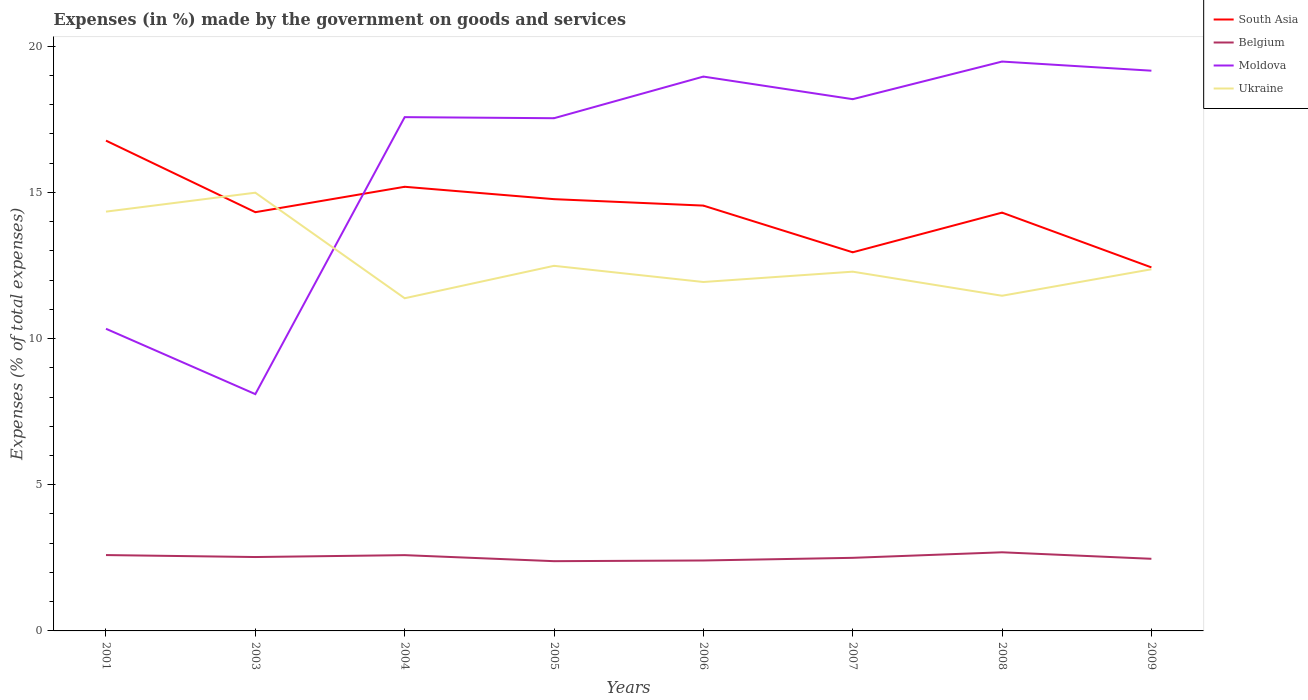How many different coloured lines are there?
Provide a short and direct response. 4. Is the number of lines equal to the number of legend labels?
Your answer should be very brief. Yes. Across all years, what is the maximum percentage of expenses made by the government on goods and services in Ukraine?
Give a very brief answer. 11.38. In which year was the percentage of expenses made by the government on goods and services in Belgium maximum?
Ensure brevity in your answer.  2005. What is the total percentage of expenses made by the government on goods and services in South Asia in the graph?
Make the answer very short. 1.89. What is the difference between the highest and the second highest percentage of expenses made by the government on goods and services in Ukraine?
Your response must be concise. 3.61. What is the difference between the highest and the lowest percentage of expenses made by the government on goods and services in South Asia?
Provide a short and direct response. 4. How many lines are there?
Provide a succinct answer. 4. How many years are there in the graph?
Your answer should be very brief. 8. What is the difference between two consecutive major ticks on the Y-axis?
Your response must be concise. 5. Are the values on the major ticks of Y-axis written in scientific E-notation?
Your response must be concise. No. Where does the legend appear in the graph?
Make the answer very short. Top right. What is the title of the graph?
Keep it short and to the point. Expenses (in %) made by the government on goods and services. What is the label or title of the X-axis?
Provide a succinct answer. Years. What is the label or title of the Y-axis?
Offer a terse response. Expenses (% of total expenses). What is the Expenses (% of total expenses) in South Asia in 2001?
Offer a very short reply. 16.77. What is the Expenses (% of total expenses) in Belgium in 2001?
Offer a terse response. 2.59. What is the Expenses (% of total expenses) in Moldova in 2001?
Your answer should be compact. 10.34. What is the Expenses (% of total expenses) in Ukraine in 2001?
Provide a short and direct response. 14.34. What is the Expenses (% of total expenses) of South Asia in 2003?
Offer a terse response. 14.32. What is the Expenses (% of total expenses) of Belgium in 2003?
Give a very brief answer. 2.53. What is the Expenses (% of total expenses) of Moldova in 2003?
Make the answer very short. 8.1. What is the Expenses (% of total expenses) in Ukraine in 2003?
Make the answer very short. 14.99. What is the Expenses (% of total expenses) in South Asia in 2004?
Provide a succinct answer. 15.19. What is the Expenses (% of total expenses) in Belgium in 2004?
Offer a very short reply. 2.59. What is the Expenses (% of total expenses) of Moldova in 2004?
Your answer should be compact. 17.57. What is the Expenses (% of total expenses) of Ukraine in 2004?
Give a very brief answer. 11.38. What is the Expenses (% of total expenses) of South Asia in 2005?
Your answer should be very brief. 14.77. What is the Expenses (% of total expenses) in Belgium in 2005?
Offer a terse response. 2.39. What is the Expenses (% of total expenses) in Moldova in 2005?
Give a very brief answer. 17.54. What is the Expenses (% of total expenses) of Ukraine in 2005?
Keep it short and to the point. 12.49. What is the Expenses (% of total expenses) in South Asia in 2006?
Offer a terse response. 14.55. What is the Expenses (% of total expenses) in Belgium in 2006?
Your answer should be compact. 2.41. What is the Expenses (% of total expenses) in Moldova in 2006?
Provide a short and direct response. 18.96. What is the Expenses (% of total expenses) in Ukraine in 2006?
Your response must be concise. 11.94. What is the Expenses (% of total expenses) in South Asia in 2007?
Provide a succinct answer. 12.95. What is the Expenses (% of total expenses) in Belgium in 2007?
Offer a terse response. 2.5. What is the Expenses (% of total expenses) in Moldova in 2007?
Offer a terse response. 18.19. What is the Expenses (% of total expenses) of Ukraine in 2007?
Your response must be concise. 12.29. What is the Expenses (% of total expenses) of South Asia in 2008?
Offer a very short reply. 14.31. What is the Expenses (% of total expenses) of Belgium in 2008?
Your answer should be very brief. 2.69. What is the Expenses (% of total expenses) of Moldova in 2008?
Provide a short and direct response. 19.48. What is the Expenses (% of total expenses) of Ukraine in 2008?
Offer a terse response. 11.47. What is the Expenses (% of total expenses) in South Asia in 2009?
Your response must be concise. 12.44. What is the Expenses (% of total expenses) of Belgium in 2009?
Ensure brevity in your answer.  2.47. What is the Expenses (% of total expenses) in Moldova in 2009?
Your answer should be very brief. 19.16. What is the Expenses (% of total expenses) of Ukraine in 2009?
Provide a short and direct response. 12.37. Across all years, what is the maximum Expenses (% of total expenses) in South Asia?
Make the answer very short. 16.77. Across all years, what is the maximum Expenses (% of total expenses) of Belgium?
Offer a terse response. 2.69. Across all years, what is the maximum Expenses (% of total expenses) in Moldova?
Ensure brevity in your answer.  19.48. Across all years, what is the maximum Expenses (% of total expenses) of Ukraine?
Ensure brevity in your answer.  14.99. Across all years, what is the minimum Expenses (% of total expenses) of South Asia?
Ensure brevity in your answer.  12.44. Across all years, what is the minimum Expenses (% of total expenses) of Belgium?
Offer a very short reply. 2.39. Across all years, what is the minimum Expenses (% of total expenses) in Moldova?
Make the answer very short. 8.1. Across all years, what is the minimum Expenses (% of total expenses) in Ukraine?
Offer a terse response. 11.38. What is the total Expenses (% of total expenses) of South Asia in the graph?
Your answer should be compact. 115.3. What is the total Expenses (% of total expenses) in Belgium in the graph?
Provide a short and direct response. 20.17. What is the total Expenses (% of total expenses) in Moldova in the graph?
Keep it short and to the point. 129.34. What is the total Expenses (% of total expenses) of Ukraine in the graph?
Your response must be concise. 101.26. What is the difference between the Expenses (% of total expenses) of South Asia in 2001 and that in 2003?
Keep it short and to the point. 2.45. What is the difference between the Expenses (% of total expenses) of Belgium in 2001 and that in 2003?
Your answer should be compact. 0.07. What is the difference between the Expenses (% of total expenses) in Moldova in 2001 and that in 2003?
Make the answer very short. 2.24. What is the difference between the Expenses (% of total expenses) of Ukraine in 2001 and that in 2003?
Keep it short and to the point. -0.65. What is the difference between the Expenses (% of total expenses) of South Asia in 2001 and that in 2004?
Give a very brief answer. 1.58. What is the difference between the Expenses (% of total expenses) of Belgium in 2001 and that in 2004?
Your answer should be compact. 0. What is the difference between the Expenses (% of total expenses) of Moldova in 2001 and that in 2004?
Your response must be concise. -7.24. What is the difference between the Expenses (% of total expenses) in Ukraine in 2001 and that in 2004?
Offer a terse response. 2.96. What is the difference between the Expenses (% of total expenses) in South Asia in 2001 and that in 2005?
Provide a succinct answer. 2. What is the difference between the Expenses (% of total expenses) of Belgium in 2001 and that in 2005?
Make the answer very short. 0.21. What is the difference between the Expenses (% of total expenses) in Moldova in 2001 and that in 2005?
Ensure brevity in your answer.  -7.2. What is the difference between the Expenses (% of total expenses) of Ukraine in 2001 and that in 2005?
Your response must be concise. 1.85. What is the difference between the Expenses (% of total expenses) of South Asia in 2001 and that in 2006?
Provide a succinct answer. 2.22. What is the difference between the Expenses (% of total expenses) in Belgium in 2001 and that in 2006?
Ensure brevity in your answer.  0.19. What is the difference between the Expenses (% of total expenses) in Moldova in 2001 and that in 2006?
Ensure brevity in your answer.  -8.63. What is the difference between the Expenses (% of total expenses) in Ukraine in 2001 and that in 2006?
Offer a very short reply. 2.41. What is the difference between the Expenses (% of total expenses) of South Asia in 2001 and that in 2007?
Ensure brevity in your answer.  3.82. What is the difference between the Expenses (% of total expenses) in Belgium in 2001 and that in 2007?
Offer a terse response. 0.09. What is the difference between the Expenses (% of total expenses) of Moldova in 2001 and that in 2007?
Your answer should be compact. -7.85. What is the difference between the Expenses (% of total expenses) of Ukraine in 2001 and that in 2007?
Your response must be concise. 2.05. What is the difference between the Expenses (% of total expenses) in South Asia in 2001 and that in 2008?
Your response must be concise. 2.46. What is the difference between the Expenses (% of total expenses) in Belgium in 2001 and that in 2008?
Make the answer very short. -0.09. What is the difference between the Expenses (% of total expenses) of Moldova in 2001 and that in 2008?
Provide a succinct answer. -9.14. What is the difference between the Expenses (% of total expenses) of Ukraine in 2001 and that in 2008?
Ensure brevity in your answer.  2.88. What is the difference between the Expenses (% of total expenses) in South Asia in 2001 and that in 2009?
Make the answer very short. 4.34. What is the difference between the Expenses (% of total expenses) of Belgium in 2001 and that in 2009?
Keep it short and to the point. 0.13. What is the difference between the Expenses (% of total expenses) in Moldova in 2001 and that in 2009?
Your response must be concise. -8.83. What is the difference between the Expenses (% of total expenses) in Ukraine in 2001 and that in 2009?
Provide a short and direct response. 1.97. What is the difference between the Expenses (% of total expenses) of South Asia in 2003 and that in 2004?
Your response must be concise. -0.87. What is the difference between the Expenses (% of total expenses) of Belgium in 2003 and that in 2004?
Offer a terse response. -0.06. What is the difference between the Expenses (% of total expenses) in Moldova in 2003 and that in 2004?
Offer a very short reply. -9.47. What is the difference between the Expenses (% of total expenses) in Ukraine in 2003 and that in 2004?
Your response must be concise. 3.61. What is the difference between the Expenses (% of total expenses) of South Asia in 2003 and that in 2005?
Your answer should be compact. -0.45. What is the difference between the Expenses (% of total expenses) in Belgium in 2003 and that in 2005?
Your response must be concise. 0.14. What is the difference between the Expenses (% of total expenses) in Moldova in 2003 and that in 2005?
Your answer should be very brief. -9.44. What is the difference between the Expenses (% of total expenses) in Ukraine in 2003 and that in 2005?
Ensure brevity in your answer.  2.5. What is the difference between the Expenses (% of total expenses) in South Asia in 2003 and that in 2006?
Offer a terse response. -0.23. What is the difference between the Expenses (% of total expenses) in Belgium in 2003 and that in 2006?
Your response must be concise. 0.12. What is the difference between the Expenses (% of total expenses) in Moldova in 2003 and that in 2006?
Offer a terse response. -10.86. What is the difference between the Expenses (% of total expenses) in Ukraine in 2003 and that in 2006?
Make the answer very short. 3.05. What is the difference between the Expenses (% of total expenses) in South Asia in 2003 and that in 2007?
Give a very brief answer. 1.37. What is the difference between the Expenses (% of total expenses) in Belgium in 2003 and that in 2007?
Make the answer very short. 0.03. What is the difference between the Expenses (% of total expenses) of Moldova in 2003 and that in 2007?
Offer a terse response. -10.09. What is the difference between the Expenses (% of total expenses) of Ukraine in 2003 and that in 2007?
Provide a succinct answer. 2.7. What is the difference between the Expenses (% of total expenses) in South Asia in 2003 and that in 2008?
Your answer should be compact. 0.01. What is the difference between the Expenses (% of total expenses) of Belgium in 2003 and that in 2008?
Your response must be concise. -0.16. What is the difference between the Expenses (% of total expenses) of Moldova in 2003 and that in 2008?
Your answer should be compact. -11.38. What is the difference between the Expenses (% of total expenses) of Ukraine in 2003 and that in 2008?
Your answer should be compact. 3.53. What is the difference between the Expenses (% of total expenses) in South Asia in 2003 and that in 2009?
Give a very brief answer. 1.89. What is the difference between the Expenses (% of total expenses) in Belgium in 2003 and that in 2009?
Offer a very short reply. 0.06. What is the difference between the Expenses (% of total expenses) in Moldova in 2003 and that in 2009?
Your answer should be compact. -11.06. What is the difference between the Expenses (% of total expenses) in Ukraine in 2003 and that in 2009?
Offer a very short reply. 2.62. What is the difference between the Expenses (% of total expenses) in South Asia in 2004 and that in 2005?
Your answer should be very brief. 0.42. What is the difference between the Expenses (% of total expenses) of Belgium in 2004 and that in 2005?
Make the answer very short. 0.21. What is the difference between the Expenses (% of total expenses) of Moldova in 2004 and that in 2005?
Make the answer very short. 0.04. What is the difference between the Expenses (% of total expenses) of Ukraine in 2004 and that in 2005?
Offer a very short reply. -1.11. What is the difference between the Expenses (% of total expenses) in South Asia in 2004 and that in 2006?
Your answer should be compact. 0.64. What is the difference between the Expenses (% of total expenses) of Belgium in 2004 and that in 2006?
Provide a succinct answer. 0.18. What is the difference between the Expenses (% of total expenses) of Moldova in 2004 and that in 2006?
Provide a short and direct response. -1.39. What is the difference between the Expenses (% of total expenses) in Ukraine in 2004 and that in 2006?
Provide a succinct answer. -0.56. What is the difference between the Expenses (% of total expenses) of South Asia in 2004 and that in 2007?
Your answer should be very brief. 2.24. What is the difference between the Expenses (% of total expenses) of Belgium in 2004 and that in 2007?
Offer a very short reply. 0.09. What is the difference between the Expenses (% of total expenses) in Moldova in 2004 and that in 2007?
Your response must be concise. -0.61. What is the difference between the Expenses (% of total expenses) in Ukraine in 2004 and that in 2007?
Provide a succinct answer. -0.91. What is the difference between the Expenses (% of total expenses) in South Asia in 2004 and that in 2008?
Your answer should be very brief. 0.88. What is the difference between the Expenses (% of total expenses) of Belgium in 2004 and that in 2008?
Provide a succinct answer. -0.1. What is the difference between the Expenses (% of total expenses) of Moldova in 2004 and that in 2008?
Make the answer very short. -1.9. What is the difference between the Expenses (% of total expenses) of Ukraine in 2004 and that in 2008?
Keep it short and to the point. -0.09. What is the difference between the Expenses (% of total expenses) in South Asia in 2004 and that in 2009?
Offer a very short reply. 2.76. What is the difference between the Expenses (% of total expenses) in Belgium in 2004 and that in 2009?
Ensure brevity in your answer.  0.13. What is the difference between the Expenses (% of total expenses) in Moldova in 2004 and that in 2009?
Make the answer very short. -1.59. What is the difference between the Expenses (% of total expenses) in Ukraine in 2004 and that in 2009?
Your response must be concise. -0.99. What is the difference between the Expenses (% of total expenses) of South Asia in 2005 and that in 2006?
Your answer should be very brief. 0.22. What is the difference between the Expenses (% of total expenses) of Belgium in 2005 and that in 2006?
Provide a short and direct response. -0.02. What is the difference between the Expenses (% of total expenses) in Moldova in 2005 and that in 2006?
Your answer should be compact. -1.42. What is the difference between the Expenses (% of total expenses) in Ukraine in 2005 and that in 2006?
Provide a short and direct response. 0.55. What is the difference between the Expenses (% of total expenses) of South Asia in 2005 and that in 2007?
Offer a terse response. 1.82. What is the difference between the Expenses (% of total expenses) in Belgium in 2005 and that in 2007?
Give a very brief answer. -0.11. What is the difference between the Expenses (% of total expenses) of Moldova in 2005 and that in 2007?
Your response must be concise. -0.65. What is the difference between the Expenses (% of total expenses) of Ukraine in 2005 and that in 2007?
Make the answer very short. 0.2. What is the difference between the Expenses (% of total expenses) in South Asia in 2005 and that in 2008?
Offer a terse response. 0.46. What is the difference between the Expenses (% of total expenses) in Belgium in 2005 and that in 2008?
Give a very brief answer. -0.3. What is the difference between the Expenses (% of total expenses) of Moldova in 2005 and that in 2008?
Make the answer very short. -1.94. What is the difference between the Expenses (% of total expenses) of Ukraine in 2005 and that in 2008?
Keep it short and to the point. 1.02. What is the difference between the Expenses (% of total expenses) in South Asia in 2005 and that in 2009?
Offer a terse response. 2.33. What is the difference between the Expenses (% of total expenses) of Belgium in 2005 and that in 2009?
Offer a very short reply. -0.08. What is the difference between the Expenses (% of total expenses) in Moldova in 2005 and that in 2009?
Offer a terse response. -1.63. What is the difference between the Expenses (% of total expenses) of Ukraine in 2005 and that in 2009?
Your answer should be compact. 0.12. What is the difference between the Expenses (% of total expenses) in South Asia in 2006 and that in 2007?
Your answer should be very brief. 1.6. What is the difference between the Expenses (% of total expenses) of Belgium in 2006 and that in 2007?
Give a very brief answer. -0.09. What is the difference between the Expenses (% of total expenses) in Moldova in 2006 and that in 2007?
Your answer should be very brief. 0.77. What is the difference between the Expenses (% of total expenses) in Ukraine in 2006 and that in 2007?
Ensure brevity in your answer.  -0.35. What is the difference between the Expenses (% of total expenses) of South Asia in 2006 and that in 2008?
Your response must be concise. 0.24. What is the difference between the Expenses (% of total expenses) of Belgium in 2006 and that in 2008?
Your answer should be very brief. -0.28. What is the difference between the Expenses (% of total expenses) in Moldova in 2006 and that in 2008?
Ensure brevity in your answer.  -0.51. What is the difference between the Expenses (% of total expenses) of Ukraine in 2006 and that in 2008?
Your response must be concise. 0.47. What is the difference between the Expenses (% of total expenses) of South Asia in 2006 and that in 2009?
Provide a short and direct response. 2.11. What is the difference between the Expenses (% of total expenses) of Belgium in 2006 and that in 2009?
Offer a very short reply. -0.06. What is the difference between the Expenses (% of total expenses) of Moldova in 2006 and that in 2009?
Offer a very short reply. -0.2. What is the difference between the Expenses (% of total expenses) in Ukraine in 2006 and that in 2009?
Your answer should be very brief. -0.43. What is the difference between the Expenses (% of total expenses) in South Asia in 2007 and that in 2008?
Keep it short and to the point. -1.36. What is the difference between the Expenses (% of total expenses) of Belgium in 2007 and that in 2008?
Give a very brief answer. -0.19. What is the difference between the Expenses (% of total expenses) in Moldova in 2007 and that in 2008?
Provide a short and direct response. -1.29. What is the difference between the Expenses (% of total expenses) in Ukraine in 2007 and that in 2008?
Ensure brevity in your answer.  0.82. What is the difference between the Expenses (% of total expenses) in South Asia in 2007 and that in 2009?
Provide a short and direct response. 0.52. What is the difference between the Expenses (% of total expenses) of Belgium in 2007 and that in 2009?
Provide a short and direct response. 0.03. What is the difference between the Expenses (% of total expenses) in Moldova in 2007 and that in 2009?
Your answer should be very brief. -0.97. What is the difference between the Expenses (% of total expenses) in Ukraine in 2007 and that in 2009?
Provide a short and direct response. -0.08. What is the difference between the Expenses (% of total expenses) of South Asia in 2008 and that in 2009?
Your answer should be very brief. 1.87. What is the difference between the Expenses (% of total expenses) in Belgium in 2008 and that in 2009?
Offer a very short reply. 0.22. What is the difference between the Expenses (% of total expenses) of Moldova in 2008 and that in 2009?
Give a very brief answer. 0.31. What is the difference between the Expenses (% of total expenses) in Ukraine in 2008 and that in 2009?
Your response must be concise. -0.91. What is the difference between the Expenses (% of total expenses) in South Asia in 2001 and the Expenses (% of total expenses) in Belgium in 2003?
Give a very brief answer. 14.24. What is the difference between the Expenses (% of total expenses) in South Asia in 2001 and the Expenses (% of total expenses) in Moldova in 2003?
Give a very brief answer. 8.67. What is the difference between the Expenses (% of total expenses) of South Asia in 2001 and the Expenses (% of total expenses) of Ukraine in 2003?
Provide a succinct answer. 1.78. What is the difference between the Expenses (% of total expenses) of Belgium in 2001 and the Expenses (% of total expenses) of Moldova in 2003?
Make the answer very short. -5.5. What is the difference between the Expenses (% of total expenses) of Belgium in 2001 and the Expenses (% of total expenses) of Ukraine in 2003?
Your answer should be very brief. -12.4. What is the difference between the Expenses (% of total expenses) in Moldova in 2001 and the Expenses (% of total expenses) in Ukraine in 2003?
Your answer should be very brief. -4.65. What is the difference between the Expenses (% of total expenses) in South Asia in 2001 and the Expenses (% of total expenses) in Belgium in 2004?
Your answer should be very brief. 14.18. What is the difference between the Expenses (% of total expenses) in South Asia in 2001 and the Expenses (% of total expenses) in Moldova in 2004?
Your answer should be very brief. -0.8. What is the difference between the Expenses (% of total expenses) in South Asia in 2001 and the Expenses (% of total expenses) in Ukraine in 2004?
Provide a short and direct response. 5.39. What is the difference between the Expenses (% of total expenses) in Belgium in 2001 and the Expenses (% of total expenses) in Moldova in 2004?
Provide a short and direct response. -14.98. What is the difference between the Expenses (% of total expenses) of Belgium in 2001 and the Expenses (% of total expenses) of Ukraine in 2004?
Provide a short and direct response. -8.79. What is the difference between the Expenses (% of total expenses) in Moldova in 2001 and the Expenses (% of total expenses) in Ukraine in 2004?
Ensure brevity in your answer.  -1.04. What is the difference between the Expenses (% of total expenses) in South Asia in 2001 and the Expenses (% of total expenses) in Belgium in 2005?
Give a very brief answer. 14.39. What is the difference between the Expenses (% of total expenses) of South Asia in 2001 and the Expenses (% of total expenses) of Moldova in 2005?
Your answer should be compact. -0.77. What is the difference between the Expenses (% of total expenses) of South Asia in 2001 and the Expenses (% of total expenses) of Ukraine in 2005?
Provide a succinct answer. 4.28. What is the difference between the Expenses (% of total expenses) in Belgium in 2001 and the Expenses (% of total expenses) in Moldova in 2005?
Your answer should be very brief. -14.94. What is the difference between the Expenses (% of total expenses) in Belgium in 2001 and the Expenses (% of total expenses) in Ukraine in 2005?
Provide a short and direct response. -9.89. What is the difference between the Expenses (% of total expenses) of Moldova in 2001 and the Expenses (% of total expenses) of Ukraine in 2005?
Keep it short and to the point. -2.15. What is the difference between the Expenses (% of total expenses) of South Asia in 2001 and the Expenses (% of total expenses) of Belgium in 2006?
Your response must be concise. 14.36. What is the difference between the Expenses (% of total expenses) in South Asia in 2001 and the Expenses (% of total expenses) in Moldova in 2006?
Offer a very short reply. -2.19. What is the difference between the Expenses (% of total expenses) in South Asia in 2001 and the Expenses (% of total expenses) in Ukraine in 2006?
Your response must be concise. 4.84. What is the difference between the Expenses (% of total expenses) of Belgium in 2001 and the Expenses (% of total expenses) of Moldova in 2006?
Provide a succinct answer. -16.37. What is the difference between the Expenses (% of total expenses) of Belgium in 2001 and the Expenses (% of total expenses) of Ukraine in 2006?
Ensure brevity in your answer.  -9.34. What is the difference between the Expenses (% of total expenses) in Moldova in 2001 and the Expenses (% of total expenses) in Ukraine in 2006?
Make the answer very short. -1.6. What is the difference between the Expenses (% of total expenses) in South Asia in 2001 and the Expenses (% of total expenses) in Belgium in 2007?
Provide a short and direct response. 14.27. What is the difference between the Expenses (% of total expenses) in South Asia in 2001 and the Expenses (% of total expenses) in Moldova in 2007?
Your response must be concise. -1.42. What is the difference between the Expenses (% of total expenses) of South Asia in 2001 and the Expenses (% of total expenses) of Ukraine in 2007?
Provide a short and direct response. 4.48. What is the difference between the Expenses (% of total expenses) of Belgium in 2001 and the Expenses (% of total expenses) of Moldova in 2007?
Keep it short and to the point. -15.59. What is the difference between the Expenses (% of total expenses) of Belgium in 2001 and the Expenses (% of total expenses) of Ukraine in 2007?
Keep it short and to the point. -9.69. What is the difference between the Expenses (% of total expenses) of Moldova in 2001 and the Expenses (% of total expenses) of Ukraine in 2007?
Keep it short and to the point. -1.95. What is the difference between the Expenses (% of total expenses) of South Asia in 2001 and the Expenses (% of total expenses) of Belgium in 2008?
Make the answer very short. 14.08. What is the difference between the Expenses (% of total expenses) of South Asia in 2001 and the Expenses (% of total expenses) of Moldova in 2008?
Give a very brief answer. -2.7. What is the difference between the Expenses (% of total expenses) in South Asia in 2001 and the Expenses (% of total expenses) in Ukraine in 2008?
Your answer should be compact. 5.31. What is the difference between the Expenses (% of total expenses) of Belgium in 2001 and the Expenses (% of total expenses) of Moldova in 2008?
Provide a short and direct response. -16.88. What is the difference between the Expenses (% of total expenses) in Belgium in 2001 and the Expenses (% of total expenses) in Ukraine in 2008?
Your answer should be very brief. -8.87. What is the difference between the Expenses (% of total expenses) in Moldova in 2001 and the Expenses (% of total expenses) in Ukraine in 2008?
Provide a short and direct response. -1.13. What is the difference between the Expenses (% of total expenses) in South Asia in 2001 and the Expenses (% of total expenses) in Belgium in 2009?
Give a very brief answer. 14.3. What is the difference between the Expenses (% of total expenses) in South Asia in 2001 and the Expenses (% of total expenses) in Moldova in 2009?
Offer a very short reply. -2.39. What is the difference between the Expenses (% of total expenses) of South Asia in 2001 and the Expenses (% of total expenses) of Ukraine in 2009?
Provide a succinct answer. 4.4. What is the difference between the Expenses (% of total expenses) in Belgium in 2001 and the Expenses (% of total expenses) in Moldova in 2009?
Provide a short and direct response. -16.57. What is the difference between the Expenses (% of total expenses) in Belgium in 2001 and the Expenses (% of total expenses) in Ukraine in 2009?
Offer a terse response. -9.78. What is the difference between the Expenses (% of total expenses) of Moldova in 2001 and the Expenses (% of total expenses) of Ukraine in 2009?
Keep it short and to the point. -2.03. What is the difference between the Expenses (% of total expenses) of South Asia in 2003 and the Expenses (% of total expenses) of Belgium in 2004?
Offer a terse response. 11.73. What is the difference between the Expenses (% of total expenses) in South Asia in 2003 and the Expenses (% of total expenses) in Moldova in 2004?
Your answer should be compact. -3.25. What is the difference between the Expenses (% of total expenses) in South Asia in 2003 and the Expenses (% of total expenses) in Ukraine in 2004?
Ensure brevity in your answer.  2.94. What is the difference between the Expenses (% of total expenses) of Belgium in 2003 and the Expenses (% of total expenses) of Moldova in 2004?
Offer a terse response. -15.05. What is the difference between the Expenses (% of total expenses) in Belgium in 2003 and the Expenses (% of total expenses) in Ukraine in 2004?
Keep it short and to the point. -8.85. What is the difference between the Expenses (% of total expenses) in Moldova in 2003 and the Expenses (% of total expenses) in Ukraine in 2004?
Offer a very short reply. -3.28. What is the difference between the Expenses (% of total expenses) in South Asia in 2003 and the Expenses (% of total expenses) in Belgium in 2005?
Keep it short and to the point. 11.94. What is the difference between the Expenses (% of total expenses) of South Asia in 2003 and the Expenses (% of total expenses) of Moldova in 2005?
Make the answer very short. -3.21. What is the difference between the Expenses (% of total expenses) of South Asia in 2003 and the Expenses (% of total expenses) of Ukraine in 2005?
Offer a very short reply. 1.83. What is the difference between the Expenses (% of total expenses) in Belgium in 2003 and the Expenses (% of total expenses) in Moldova in 2005?
Your answer should be compact. -15.01. What is the difference between the Expenses (% of total expenses) of Belgium in 2003 and the Expenses (% of total expenses) of Ukraine in 2005?
Provide a succinct answer. -9.96. What is the difference between the Expenses (% of total expenses) in Moldova in 2003 and the Expenses (% of total expenses) in Ukraine in 2005?
Offer a very short reply. -4.39. What is the difference between the Expenses (% of total expenses) of South Asia in 2003 and the Expenses (% of total expenses) of Belgium in 2006?
Your answer should be very brief. 11.91. What is the difference between the Expenses (% of total expenses) of South Asia in 2003 and the Expenses (% of total expenses) of Moldova in 2006?
Provide a succinct answer. -4.64. What is the difference between the Expenses (% of total expenses) in South Asia in 2003 and the Expenses (% of total expenses) in Ukraine in 2006?
Ensure brevity in your answer.  2.39. What is the difference between the Expenses (% of total expenses) of Belgium in 2003 and the Expenses (% of total expenses) of Moldova in 2006?
Your answer should be very brief. -16.43. What is the difference between the Expenses (% of total expenses) of Belgium in 2003 and the Expenses (% of total expenses) of Ukraine in 2006?
Provide a succinct answer. -9.41. What is the difference between the Expenses (% of total expenses) of Moldova in 2003 and the Expenses (% of total expenses) of Ukraine in 2006?
Your response must be concise. -3.84. What is the difference between the Expenses (% of total expenses) of South Asia in 2003 and the Expenses (% of total expenses) of Belgium in 2007?
Offer a terse response. 11.82. What is the difference between the Expenses (% of total expenses) in South Asia in 2003 and the Expenses (% of total expenses) in Moldova in 2007?
Your answer should be compact. -3.87. What is the difference between the Expenses (% of total expenses) in South Asia in 2003 and the Expenses (% of total expenses) in Ukraine in 2007?
Your response must be concise. 2.04. What is the difference between the Expenses (% of total expenses) of Belgium in 2003 and the Expenses (% of total expenses) of Moldova in 2007?
Offer a very short reply. -15.66. What is the difference between the Expenses (% of total expenses) of Belgium in 2003 and the Expenses (% of total expenses) of Ukraine in 2007?
Ensure brevity in your answer.  -9.76. What is the difference between the Expenses (% of total expenses) of Moldova in 2003 and the Expenses (% of total expenses) of Ukraine in 2007?
Give a very brief answer. -4.19. What is the difference between the Expenses (% of total expenses) of South Asia in 2003 and the Expenses (% of total expenses) of Belgium in 2008?
Offer a terse response. 11.63. What is the difference between the Expenses (% of total expenses) in South Asia in 2003 and the Expenses (% of total expenses) in Moldova in 2008?
Offer a terse response. -5.15. What is the difference between the Expenses (% of total expenses) in South Asia in 2003 and the Expenses (% of total expenses) in Ukraine in 2008?
Provide a short and direct response. 2.86. What is the difference between the Expenses (% of total expenses) in Belgium in 2003 and the Expenses (% of total expenses) in Moldova in 2008?
Give a very brief answer. -16.95. What is the difference between the Expenses (% of total expenses) in Belgium in 2003 and the Expenses (% of total expenses) in Ukraine in 2008?
Give a very brief answer. -8.94. What is the difference between the Expenses (% of total expenses) of Moldova in 2003 and the Expenses (% of total expenses) of Ukraine in 2008?
Your response must be concise. -3.37. What is the difference between the Expenses (% of total expenses) in South Asia in 2003 and the Expenses (% of total expenses) in Belgium in 2009?
Offer a terse response. 11.86. What is the difference between the Expenses (% of total expenses) in South Asia in 2003 and the Expenses (% of total expenses) in Moldova in 2009?
Give a very brief answer. -4.84. What is the difference between the Expenses (% of total expenses) of South Asia in 2003 and the Expenses (% of total expenses) of Ukraine in 2009?
Your response must be concise. 1.95. What is the difference between the Expenses (% of total expenses) of Belgium in 2003 and the Expenses (% of total expenses) of Moldova in 2009?
Your response must be concise. -16.64. What is the difference between the Expenses (% of total expenses) in Belgium in 2003 and the Expenses (% of total expenses) in Ukraine in 2009?
Provide a succinct answer. -9.84. What is the difference between the Expenses (% of total expenses) in Moldova in 2003 and the Expenses (% of total expenses) in Ukraine in 2009?
Make the answer very short. -4.27. What is the difference between the Expenses (% of total expenses) of South Asia in 2004 and the Expenses (% of total expenses) of Belgium in 2005?
Provide a short and direct response. 12.81. What is the difference between the Expenses (% of total expenses) in South Asia in 2004 and the Expenses (% of total expenses) in Moldova in 2005?
Ensure brevity in your answer.  -2.35. What is the difference between the Expenses (% of total expenses) in South Asia in 2004 and the Expenses (% of total expenses) in Ukraine in 2005?
Provide a succinct answer. 2.7. What is the difference between the Expenses (% of total expenses) in Belgium in 2004 and the Expenses (% of total expenses) in Moldova in 2005?
Keep it short and to the point. -14.95. What is the difference between the Expenses (% of total expenses) in Belgium in 2004 and the Expenses (% of total expenses) in Ukraine in 2005?
Your answer should be very brief. -9.9. What is the difference between the Expenses (% of total expenses) in Moldova in 2004 and the Expenses (% of total expenses) in Ukraine in 2005?
Offer a very short reply. 5.09. What is the difference between the Expenses (% of total expenses) of South Asia in 2004 and the Expenses (% of total expenses) of Belgium in 2006?
Provide a succinct answer. 12.78. What is the difference between the Expenses (% of total expenses) of South Asia in 2004 and the Expenses (% of total expenses) of Moldova in 2006?
Give a very brief answer. -3.77. What is the difference between the Expenses (% of total expenses) in South Asia in 2004 and the Expenses (% of total expenses) in Ukraine in 2006?
Your response must be concise. 3.26. What is the difference between the Expenses (% of total expenses) in Belgium in 2004 and the Expenses (% of total expenses) in Moldova in 2006?
Provide a succinct answer. -16.37. What is the difference between the Expenses (% of total expenses) of Belgium in 2004 and the Expenses (% of total expenses) of Ukraine in 2006?
Provide a succinct answer. -9.34. What is the difference between the Expenses (% of total expenses) in Moldova in 2004 and the Expenses (% of total expenses) in Ukraine in 2006?
Provide a short and direct response. 5.64. What is the difference between the Expenses (% of total expenses) in South Asia in 2004 and the Expenses (% of total expenses) in Belgium in 2007?
Make the answer very short. 12.69. What is the difference between the Expenses (% of total expenses) of South Asia in 2004 and the Expenses (% of total expenses) of Moldova in 2007?
Make the answer very short. -3. What is the difference between the Expenses (% of total expenses) of South Asia in 2004 and the Expenses (% of total expenses) of Ukraine in 2007?
Offer a terse response. 2.9. What is the difference between the Expenses (% of total expenses) in Belgium in 2004 and the Expenses (% of total expenses) in Moldova in 2007?
Keep it short and to the point. -15.6. What is the difference between the Expenses (% of total expenses) in Belgium in 2004 and the Expenses (% of total expenses) in Ukraine in 2007?
Your answer should be very brief. -9.7. What is the difference between the Expenses (% of total expenses) of Moldova in 2004 and the Expenses (% of total expenses) of Ukraine in 2007?
Offer a very short reply. 5.29. What is the difference between the Expenses (% of total expenses) of South Asia in 2004 and the Expenses (% of total expenses) of Belgium in 2008?
Give a very brief answer. 12.5. What is the difference between the Expenses (% of total expenses) of South Asia in 2004 and the Expenses (% of total expenses) of Moldova in 2008?
Make the answer very short. -4.28. What is the difference between the Expenses (% of total expenses) of South Asia in 2004 and the Expenses (% of total expenses) of Ukraine in 2008?
Give a very brief answer. 3.73. What is the difference between the Expenses (% of total expenses) of Belgium in 2004 and the Expenses (% of total expenses) of Moldova in 2008?
Your response must be concise. -16.88. What is the difference between the Expenses (% of total expenses) in Belgium in 2004 and the Expenses (% of total expenses) in Ukraine in 2008?
Keep it short and to the point. -8.87. What is the difference between the Expenses (% of total expenses) in Moldova in 2004 and the Expenses (% of total expenses) in Ukraine in 2008?
Provide a short and direct response. 6.11. What is the difference between the Expenses (% of total expenses) of South Asia in 2004 and the Expenses (% of total expenses) of Belgium in 2009?
Offer a very short reply. 12.73. What is the difference between the Expenses (% of total expenses) in South Asia in 2004 and the Expenses (% of total expenses) in Moldova in 2009?
Ensure brevity in your answer.  -3.97. What is the difference between the Expenses (% of total expenses) of South Asia in 2004 and the Expenses (% of total expenses) of Ukraine in 2009?
Your answer should be compact. 2.82. What is the difference between the Expenses (% of total expenses) of Belgium in 2004 and the Expenses (% of total expenses) of Moldova in 2009?
Offer a terse response. -16.57. What is the difference between the Expenses (% of total expenses) of Belgium in 2004 and the Expenses (% of total expenses) of Ukraine in 2009?
Your answer should be very brief. -9.78. What is the difference between the Expenses (% of total expenses) of Moldova in 2004 and the Expenses (% of total expenses) of Ukraine in 2009?
Provide a succinct answer. 5.2. What is the difference between the Expenses (% of total expenses) of South Asia in 2005 and the Expenses (% of total expenses) of Belgium in 2006?
Offer a terse response. 12.36. What is the difference between the Expenses (% of total expenses) in South Asia in 2005 and the Expenses (% of total expenses) in Moldova in 2006?
Your answer should be compact. -4.19. What is the difference between the Expenses (% of total expenses) of South Asia in 2005 and the Expenses (% of total expenses) of Ukraine in 2006?
Make the answer very short. 2.83. What is the difference between the Expenses (% of total expenses) of Belgium in 2005 and the Expenses (% of total expenses) of Moldova in 2006?
Your answer should be compact. -16.58. What is the difference between the Expenses (% of total expenses) in Belgium in 2005 and the Expenses (% of total expenses) in Ukraine in 2006?
Offer a very short reply. -9.55. What is the difference between the Expenses (% of total expenses) of Moldova in 2005 and the Expenses (% of total expenses) of Ukraine in 2006?
Offer a terse response. 5.6. What is the difference between the Expenses (% of total expenses) in South Asia in 2005 and the Expenses (% of total expenses) in Belgium in 2007?
Your response must be concise. 12.27. What is the difference between the Expenses (% of total expenses) of South Asia in 2005 and the Expenses (% of total expenses) of Moldova in 2007?
Offer a terse response. -3.42. What is the difference between the Expenses (% of total expenses) in South Asia in 2005 and the Expenses (% of total expenses) in Ukraine in 2007?
Your response must be concise. 2.48. What is the difference between the Expenses (% of total expenses) of Belgium in 2005 and the Expenses (% of total expenses) of Moldova in 2007?
Keep it short and to the point. -15.8. What is the difference between the Expenses (% of total expenses) of Belgium in 2005 and the Expenses (% of total expenses) of Ukraine in 2007?
Provide a short and direct response. -9.9. What is the difference between the Expenses (% of total expenses) of Moldova in 2005 and the Expenses (% of total expenses) of Ukraine in 2007?
Ensure brevity in your answer.  5.25. What is the difference between the Expenses (% of total expenses) in South Asia in 2005 and the Expenses (% of total expenses) in Belgium in 2008?
Your response must be concise. 12.08. What is the difference between the Expenses (% of total expenses) in South Asia in 2005 and the Expenses (% of total expenses) in Moldova in 2008?
Keep it short and to the point. -4.71. What is the difference between the Expenses (% of total expenses) of South Asia in 2005 and the Expenses (% of total expenses) of Ukraine in 2008?
Your answer should be compact. 3.3. What is the difference between the Expenses (% of total expenses) of Belgium in 2005 and the Expenses (% of total expenses) of Moldova in 2008?
Your response must be concise. -17.09. What is the difference between the Expenses (% of total expenses) in Belgium in 2005 and the Expenses (% of total expenses) in Ukraine in 2008?
Ensure brevity in your answer.  -9.08. What is the difference between the Expenses (% of total expenses) of Moldova in 2005 and the Expenses (% of total expenses) of Ukraine in 2008?
Give a very brief answer. 6.07. What is the difference between the Expenses (% of total expenses) in South Asia in 2005 and the Expenses (% of total expenses) in Belgium in 2009?
Offer a very short reply. 12.3. What is the difference between the Expenses (% of total expenses) of South Asia in 2005 and the Expenses (% of total expenses) of Moldova in 2009?
Offer a very short reply. -4.39. What is the difference between the Expenses (% of total expenses) of South Asia in 2005 and the Expenses (% of total expenses) of Ukraine in 2009?
Ensure brevity in your answer.  2.4. What is the difference between the Expenses (% of total expenses) in Belgium in 2005 and the Expenses (% of total expenses) in Moldova in 2009?
Your response must be concise. -16.78. What is the difference between the Expenses (% of total expenses) in Belgium in 2005 and the Expenses (% of total expenses) in Ukraine in 2009?
Your answer should be compact. -9.98. What is the difference between the Expenses (% of total expenses) in Moldova in 2005 and the Expenses (% of total expenses) in Ukraine in 2009?
Offer a very short reply. 5.17. What is the difference between the Expenses (% of total expenses) of South Asia in 2006 and the Expenses (% of total expenses) of Belgium in 2007?
Provide a short and direct response. 12.05. What is the difference between the Expenses (% of total expenses) in South Asia in 2006 and the Expenses (% of total expenses) in Moldova in 2007?
Make the answer very short. -3.64. What is the difference between the Expenses (% of total expenses) in South Asia in 2006 and the Expenses (% of total expenses) in Ukraine in 2007?
Your answer should be very brief. 2.26. What is the difference between the Expenses (% of total expenses) in Belgium in 2006 and the Expenses (% of total expenses) in Moldova in 2007?
Your response must be concise. -15.78. What is the difference between the Expenses (% of total expenses) of Belgium in 2006 and the Expenses (% of total expenses) of Ukraine in 2007?
Your answer should be very brief. -9.88. What is the difference between the Expenses (% of total expenses) in Moldova in 2006 and the Expenses (% of total expenses) in Ukraine in 2007?
Ensure brevity in your answer.  6.67. What is the difference between the Expenses (% of total expenses) of South Asia in 2006 and the Expenses (% of total expenses) of Belgium in 2008?
Your answer should be compact. 11.86. What is the difference between the Expenses (% of total expenses) of South Asia in 2006 and the Expenses (% of total expenses) of Moldova in 2008?
Your response must be concise. -4.93. What is the difference between the Expenses (% of total expenses) in South Asia in 2006 and the Expenses (% of total expenses) in Ukraine in 2008?
Give a very brief answer. 3.08. What is the difference between the Expenses (% of total expenses) in Belgium in 2006 and the Expenses (% of total expenses) in Moldova in 2008?
Ensure brevity in your answer.  -17.07. What is the difference between the Expenses (% of total expenses) of Belgium in 2006 and the Expenses (% of total expenses) of Ukraine in 2008?
Give a very brief answer. -9.06. What is the difference between the Expenses (% of total expenses) of Moldova in 2006 and the Expenses (% of total expenses) of Ukraine in 2008?
Ensure brevity in your answer.  7.5. What is the difference between the Expenses (% of total expenses) of South Asia in 2006 and the Expenses (% of total expenses) of Belgium in 2009?
Offer a very short reply. 12.08. What is the difference between the Expenses (% of total expenses) in South Asia in 2006 and the Expenses (% of total expenses) in Moldova in 2009?
Your answer should be compact. -4.61. What is the difference between the Expenses (% of total expenses) of South Asia in 2006 and the Expenses (% of total expenses) of Ukraine in 2009?
Keep it short and to the point. 2.18. What is the difference between the Expenses (% of total expenses) in Belgium in 2006 and the Expenses (% of total expenses) in Moldova in 2009?
Ensure brevity in your answer.  -16.75. What is the difference between the Expenses (% of total expenses) of Belgium in 2006 and the Expenses (% of total expenses) of Ukraine in 2009?
Your answer should be compact. -9.96. What is the difference between the Expenses (% of total expenses) in Moldova in 2006 and the Expenses (% of total expenses) in Ukraine in 2009?
Offer a terse response. 6.59. What is the difference between the Expenses (% of total expenses) of South Asia in 2007 and the Expenses (% of total expenses) of Belgium in 2008?
Provide a short and direct response. 10.26. What is the difference between the Expenses (% of total expenses) in South Asia in 2007 and the Expenses (% of total expenses) in Moldova in 2008?
Give a very brief answer. -6.52. What is the difference between the Expenses (% of total expenses) of South Asia in 2007 and the Expenses (% of total expenses) of Ukraine in 2008?
Provide a succinct answer. 1.49. What is the difference between the Expenses (% of total expenses) in Belgium in 2007 and the Expenses (% of total expenses) in Moldova in 2008?
Provide a succinct answer. -16.98. What is the difference between the Expenses (% of total expenses) of Belgium in 2007 and the Expenses (% of total expenses) of Ukraine in 2008?
Offer a terse response. -8.96. What is the difference between the Expenses (% of total expenses) of Moldova in 2007 and the Expenses (% of total expenses) of Ukraine in 2008?
Provide a succinct answer. 6.72. What is the difference between the Expenses (% of total expenses) in South Asia in 2007 and the Expenses (% of total expenses) in Belgium in 2009?
Make the answer very short. 10.48. What is the difference between the Expenses (% of total expenses) in South Asia in 2007 and the Expenses (% of total expenses) in Moldova in 2009?
Your answer should be very brief. -6.21. What is the difference between the Expenses (% of total expenses) in South Asia in 2007 and the Expenses (% of total expenses) in Ukraine in 2009?
Your answer should be very brief. 0.58. What is the difference between the Expenses (% of total expenses) of Belgium in 2007 and the Expenses (% of total expenses) of Moldova in 2009?
Your answer should be very brief. -16.66. What is the difference between the Expenses (% of total expenses) in Belgium in 2007 and the Expenses (% of total expenses) in Ukraine in 2009?
Provide a succinct answer. -9.87. What is the difference between the Expenses (% of total expenses) of Moldova in 2007 and the Expenses (% of total expenses) of Ukraine in 2009?
Provide a succinct answer. 5.82. What is the difference between the Expenses (% of total expenses) in South Asia in 2008 and the Expenses (% of total expenses) in Belgium in 2009?
Your response must be concise. 11.84. What is the difference between the Expenses (% of total expenses) of South Asia in 2008 and the Expenses (% of total expenses) of Moldova in 2009?
Give a very brief answer. -4.85. What is the difference between the Expenses (% of total expenses) of South Asia in 2008 and the Expenses (% of total expenses) of Ukraine in 2009?
Offer a terse response. 1.94. What is the difference between the Expenses (% of total expenses) in Belgium in 2008 and the Expenses (% of total expenses) in Moldova in 2009?
Provide a succinct answer. -16.47. What is the difference between the Expenses (% of total expenses) of Belgium in 2008 and the Expenses (% of total expenses) of Ukraine in 2009?
Ensure brevity in your answer.  -9.68. What is the difference between the Expenses (% of total expenses) in Moldova in 2008 and the Expenses (% of total expenses) in Ukraine in 2009?
Offer a very short reply. 7.11. What is the average Expenses (% of total expenses) in South Asia per year?
Ensure brevity in your answer.  14.41. What is the average Expenses (% of total expenses) of Belgium per year?
Ensure brevity in your answer.  2.52. What is the average Expenses (% of total expenses) in Moldova per year?
Provide a succinct answer. 16.17. What is the average Expenses (% of total expenses) of Ukraine per year?
Ensure brevity in your answer.  12.66. In the year 2001, what is the difference between the Expenses (% of total expenses) in South Asia and Expenses (% of total expenses) in Belgium?
Give a very brief answer. 14.18. In the year 2001, what is the difference between the Expenses (% of total expenses) of South Asia and Expenses (% of total expenses) of Moldova?
Offer a very short reply. 6.44. In the year 2001, what is the difference between the Expenses (% of total expenses) of South Asia and Expenses (% of total expenses) of Ukraine?
Provide a short and direct response. 2.43. In the year 2001, what is the difference between the Expenses (% of total expenses) in Belgium and Expenses (% of total expenses) in Moldova?
Your answer should be very brief. -7.74. In the year 2001, what is the difference between the Expenses (% of total expenses) of Belgium and Expenses (% of total expenses) of Ukraine?
Your answer should be compact. -11.75. In the year 2001, what is the difference between the Expenses (% of total expenses) in Moldova and Expenses (% of total expenses) in Ukraine?
Give a very brief answer. -4.01. In the year 2003, what is the difference between the Expenses (% of total expenses) in South Asia and Expenses (% of total expenses) in Belgium?
Your answer should be very brief. 11.8. In the year 2003, what is the difference between the Expenses (% of total expenses) in South Asia and Expenses (% of total expenses) in Moldova?
Your answer should be very brief. 6.22. In the year 2003, what is the difference between the Expenses (% of total expenses) of South Asia and Expenses (% of total expenses) of Ukraine?
Your response must be concise. -0.67. In the year 2003, what is the difference between the Expenses (% of total expenses) in Belgium and Expenses (% of total expenses) in Moldova?
Your answer should be very brief. -5.57. In the year 2003, what is the difference between the Expenses (% of total expenses) in Belgium and Expenses (% of total expenses) in Ukraine?
Your answer should be compact. -12.46. In the year 2003, what is the difference between the Expenses (% of total expenses) in Moldova and Expenses (% of total expenses) in Ukraine?
Your answer should be very brief. -6.89. In the year 2004, what is the difference between the Expenses (% of total expenses) in South Asia and Expenses (% of total expenses) in Belgium?
Make the answer very short. 12.6. In the year 2004, what is the difference between the Expenses (% of total expenses) of South Asia and Expenses (% of total expenses) of Moldova?
Provide a short and direct response. -2.38. In the year 2004, what is the difference between the Expenses (% of total expenses) in South Asia and Expenses (% of total expenses) in Ukraine?
Your response must be concise. 3.81. In the year 2004, what is the difference between the Expenses (% of total expenses) in Belgium and Expenses (% of total expenses) in Moldova?
Offer a terse response. -14.98. In the year 2004, what is the difference between the Expenses (% of total expenses) in Belgium and Expenses (% of total expenses) in Ukraine?
Ensure brevity in your answer.  -8.79. In the year 2004, what is the difference between the Expenses (% of total expenses) of Moldova and Expenses (% of total expenses) of Ukraine?
Your response must be concise. 6.19. In the year 2005, what is the difference between the Expenses (% of total expenses) in South Asia and Expenses (% of total expenses) in Belgium?
Offer a terse response. 12.38. In the year 2005, what is the difference between the Expenses (% of total expenses) of South Asia and Expenses (% of total expenses) of Moldova?
Your response must be concise. -2.77. In the year 2005, what is the difference between the Expenses (% of total expenses) in South Asia and Expenses (% of total expenses) in Ukraine?
Provide a short and direct response. 2.28. In the year 2005, what is the difference between the Expenses (% of total expenses) in Belgium and Expenses (% of total expenses) in Moldova?
Your answer should be very brief. -15.15. In the year 2005, what is the difference between the Expenses (% of total expenses) of Belgium and Expenses (% of total expenses) of Ukraine?
Your answer should be very brief. -10.1. In the year 2005, what is the difference between the Expenses (% of total expenses) of Moldova and Expenses (% of total expenses) of Ukraine?
Make the answer very short. 5.05. In the year 2006, what is the difference between the Expenses (% of total expenses) in South Asia and Expenses (% of total expenses) in Belgium?
Offer a very short reply. 12.14. In the year 2006, what is the difference between the Expenses (% of total expenses) in South Asia and Expenses (% of total expenses) in Moldova?
Provide a succinct answer. -4.41. In the year 2006, what is the difference between the Expenses (% of total expenses) in South Asia and Expenses (% of total expenses) in Ukraine?
Offer a terse response. 2.61. In the year 2006, what is the difference between the Expenses (% of total expenses) of Belgium and Expenses (% of total expenses) of Moldova?
Give a very brief answer. -16.55. In the year 2006, what is the difference between the Expenses (% of total expenses) of Belgium and Expenses (% of total expenses) of Ukraine?
Ensure brevity in your answer.  -9.53. In the year 2006, what is the difference between the Expenses (% of total expenses) in Moldova and Expenses (% of total expenses) in Ukraine?
Provide a succinct answer. 7.03. In the year 2007, what is the difference between the Expenses (% of total expenses) in South Asia and Expenses (% of total expenses) in Belgium?
Your response must be concise. 10.45. In the year 2007, what is the difference between the Expenses (% of total expenses) of South Asia and Expenses (% of total expenses) of Moldova?
Your answer should be compact. -5.24. In the year 2007, what is the difference between the Expenses (% of total expenses) in South Asia and Expenses (% of total expenses) in Ukraine?
Offer a very short reply. 0.66. In the year 2007, what is the difference between the Expenses (% of total expenses) in Belgium and Expenses (% of total expenses) in Moldova?
Your answer should be compact. -15.69. In the year 2007, what is the difference between the Expenses (% of total expenses) of Belgium and Expenses (% of total expenses) of Ukraine?
Your response must be concise. -9.79. In the year 2007, what is the difference between the Expenses (% of total expenses) of Moldova and Expenses (% of total expenses) of Ukraine?
Provide a succinct answer. 5.9. In the year 2008, what is the difference between the Expenses (% of total expenses) of South Asia and Expenses (% of total expenses) of Belgium?
Offer a very short reply. 11.62. In the year 2008, what is the difference between the Expenses (% of total expenses) of South Asia and Expenses (% of total expenses) of Moldova?
Offer a terse response. -5.17. In the year 2008, what is the difference between the Expenses (% of total expenses) in South Asia and Expenses (% of total expenses) in Ukraine?
Your answer should be very brief. 2.84. In the year 2008, what is the difference between the Expenses (% of total expenses) of Belgium and Expenses (% of total expenses) of Moldova?
Your answer should be compact. -16.79. In the year 2008, what is the difference between the Expenses (% of total expenses) in Belgium and Expenses (% of total expenses) in Ukraine?
Give a very brief answer. -8.78. In the year 2008, what is the difference between the Expenses (% of total expenses) in Moldova and Expenses (% of total expenses) in Ukraine?
Your response must be concise. 8.01. In the year 2009, what is the difference between the Expenses (% of total expenses) of South Asia and Expenses (% of total expenses) of Belgium?
Offer a very short reply. 9.97. In the year 2009, what is the difference between the Expenses (% of total expenses) in South Asia and Expenses (% of total expenses) in Moldova?
Make the answer very short. -6.73. In the year 2009, what is the difference between the Expenses (% of total expenses) in South Asia and Expenses (% of total expenses) in Ukraine?
Keep it short and to the point. 0.06. In the year 2009, what is the difference between the Expenses (% of total expenses) of Belgium and Expenses (% of total expenses) of Moldova?
Offer a terse response. -16.7. In the year 2009, what is the difference between the Expenses (% of total expenses) in Belgium and Expenses (% of total expenses) in Ukraine?
Your answer should be compact. -9.9. In the year 2009, what is the difference between the Expenses (% of total expenses) of Moldova and Expenses (% of total expenses) of Ukraine?
Offer a very short reply. 6.79. What is the ratio of the Expenses (% of total expenses) in South Asia in 2001 to that in 2003?
Provide a succinct answer. 1.17. What is the ratio of the Expenses (% of total expenses) of Belgium in 2001 to that in 2003?
Your response must be concise. 1.03. What is the ratio of the Expenses (% of total expenses) of Moldova in 2001 to that in 2003?
Your answer should be compact. 1.28. What is the ratio of the Expenses (% of total expenses) in Ukraine in 2001 to that in 2003?
Your response must be concise. 0.96. What is the ratio of the Expenses (% of total expenses) of South Asia in 2001 to that in 2004?
Provide a succinct answer. 1.1. What is the ratio of the Expenses (% of total expenses) in Moldova in 2001 to that in 2004?
Provide a succinct answer. 0.59. What is the ratio of the Expenses (% of total expenses) of Ukraine in 2001 to that in 2004?
Your answer should be very brief. 1.26. What is the ratio of the Expenses (% of total expenses) in South Asia in 2001 to that in 2005?
Keep it short and to the point. 1.14. What is the ratio of the Expenses (% of total expenses) in Belgium in 2001 to that in 2005?
Make the answer very short. 1.09. What is the ratio of the Expenses (% of total expenses) in Moldova in 2001 to that in 2005?
Provide a succinct answer. 0.59. What is the ratio of the Expenses (% of total expenses) of Ukraine in 2001 to that in 2005?
Provide a succinct answer. 1.15. What is the ratio of the Expenses (% of total expenses) of South Asia in 2001 to that in 2006?
Provide a short and direct response. 1.15. What is the ratio of the Expenses (% of total expenses) of Belgium in 2001 to that in 2006?
Keep it short and to the point. 1.08. What is the ratio of the Expenses (% of total expenses) of Moldova in 2001 to that in 2006?
Offer a very short reply. 0.55. What is the ratio of the Expenses (% of total expenses) of Ukraine in 2001 to that in 2006?
Keep it short and to the point. 1.2. What is the ratio of the Expenses (% of total expenses) in South Asia in 2001 to that in 2007?
Offer a very short reply. 1.29. What is the ratio of the Expenses (% of total expenses) of Belgium in 2001 to that in 2007?
Keep it short and to the point. 1.04. What is the ratio of the Expenses (% of total expenses) in Moldova in 2001 to that in 2007?
Keep it short and to the point. 0.57. What is the ratio of the Expenses (% of total expenses) in Ukraine in 2001 to that in 2007?
Your answer should be very brief. 1.17. What is the ratio of the Expenses (% of total expenses) of South Asia in 2001 to that in 2008?
Your answer should be compact. 1.17. What is the ratio of the Expenses (% of total expenses) of Belgium in 2001 to that in 2008?
Offer a very short reply. 0.96. What is the ratio of the Expenses (% of total expenses) in Moldova in 2001 to that in 2008?
Provide a short and direct response. 0.53. What is the ratio of the Expenses (% of total expenses) in Ukraine in 2001 to that in 2008?
Offer a terse response. 1.25. What is the ratio of the Expenses (% of total expenses) in South Asia in 2001 to that in 2009?
Offer a terse response. 1.35. What is the ratio of the Expenses (% of total expenses) of Belgium in 2001 to that in 2009?
Make the answer very short. 1.05. What is the ratio of the Expenses (% of total expenses) in Moldova in 2001 to that in 2009?
Keep it short and to the point. 0.54. What is the ratio of the Expenses (% of total expenses) in Ukraine in 2001 to that in 2009?
Your answer should be very brief. 1.16. What is the ratio of the Expenses (% of total expenses) of South Asia in 2003 to that in 2004?
Provide a short and direct response. 0.94. What is the ratio of the Expenses (% of total expenses) in Belgium in 2003 to that in 2004?
Keep it short and to the point. 0.97. What is the ratio of the Expenses (% of total expenses) of Moldova in 2003 to that in 2004?
Ensure brevity in your answer.  0.46. What is the ratio of the Expenses (% of total expenses) in Ukraine in 2003 to that in 2004?
Provide a short and direct response. 1.32. What is the ratio of the Expenses (% of total expenses) of South Asia in 2003 to that in 2005?
Provide a succinct answer. 0.97. What is the ratio of the Expenses (% of total expenses) of Belgium in 2003 to that in 2005?
Your answer should be compact. 1.06. What is the ratio of the Expenses (% of total expenses) in Moldova in 2003 to that in 2005?
Make the answer very short. 0.46. What is the ratio of the Expenses (% of total expenses) in Ukraine in 2003 to that in 2005?
Ensure brevity in your answer.  1.2. What is the ratio of the Expenses (% of total expenses) in South Asia in 2003 to that in 2006?
Keep it short and to the point. 0.98. What is the ratio of the Expenses (% of total expenses) in Belgium in 2003 to that in 2006?
Keep it short and to the point. 1.05. What is the ratio of the Expenses (% of total expenses) of Moldova in 2003 to that in 2006?
Your response must be concise. 0.43. What is the ratio of the Expenses (% of total expenses) in Ukraine in 2003 to that in 2006?
Your answer should be compact. 1.26. What is the ratio of the Expenses (% of total expenses) in South Asia in 2003 to that in 2007?
Provide a succinct answer. 1.11. What is the ratio of the Expenses (% of total expenses) in Moldova in 2003 to that in 2007?
Offer a very short reply. 0.45. What is the ratio of the Expenses (% of total expenses) in Ukraine in 2003 to that in 2007?
Ensure brevity in your answer.  1.22. What is the ratio of the Expenses (% of total expenses) of South Asia in 2003 to that in 2008?
Make the answer very short. 1. What is the ratio of the Expenses (% of total expenses) in Belgium in 2003 to that in 2008?
Your answer should be compact. 0.94. What is the ratio of the Expenses (% of total expenses) in Moldova in 2003 to that in 2008?
Your answer should be very brief. 0.42. What is the ratio of the Expenses (% of total expenses) of Ukraine in 2003 to that in 2008?
Ensure brevity in your answer.  1.31. What is the ratio of the Expenses (% of total expenses) in South Asia in 2003 to that in 2009?
Your response must be concise. 1.15. What is the ratio of the Expenses (% of total expenses) of Belgium in 2003 to that in 2009?
Your answer should be very brief. 1.02. What is the ratio of the Expenses (% of total expenses) in Moldova in 2003 to that in 2009?
Keep it short and to the point. 0.42. What is the ratio of the Expenses (% of total expenses) of Ukraine in 2003 to that in 2009?
Your answer should be compact. 1.21. What is the ratio of the Expenses (% of total expenses) in South Asia in 2004 to that in 2005?
Ensure brevity in your answer.  1.03. What is the ratio of the Expenses (% of total expenses) of Belgium in 2004 to that in 2005?
Provide a succinct answer. 1.09. What is the ratio of the Expenses (% of total expenses) of Moldova in 2004 to that in 2005?
Offer a terse response. 1. What is the ratio of the Expenses (% of total expenses) of Ukraine in 2004 to that in 2005?
Provide a succinct answer. 0.91. What is the ratio of the Expenses (% of total expenses) of South Asia in 2004 to that in 2006?
Offer a very short reply. 1.04. What is the ratio of the Expenses (% of total expenses) of Belgium in 2004 to that in 2006?
Provide a short and direct response. 1.08. What is the ratio of the Expenses (% of total expenses) in Moldova in 2004 to that in 2006?
Keep it short and to the point. 0.93. What is the ratio of the Expenses (% of total expenses) in Ukraine in 2004 to that in 2006?
Give a very brief answer. 0.95. What is the ratio of the Expenses (% of total expenses) in South Asia in 2004 to that in 2007?
Offer a very short reply. 1.17. What is the ratio of the Expenses (% of total expenses) in Belgium in 2004 to that in 2007?
Give a very brief answer. 1.04. What is the ratio of the Expenses (% of total expenses) in Moldova in 2004 to that in 2007?
Offer a very short reply. 0.97. What is the ratio of the Expenses (% of total expenses) in Ukraine in 2004 to that in 2007?
Give a very brief answer. 0.93. What is the ratio of the Expenses (% of total expenses) of South Asia in 2004 to that in 2008?
Your answer should be very brief. 1.06. What is the ratio of the Expenses (% of total expenses) of Belgium in 2004 to that in 2008?
Your answer should be compact. 0.96. What is the ratio of the Expenses (% of total expenses) in Moldova in 2004 to that in 2008?
Offer a very short reply. 0.9. What is the ratio of the Expenses (% of total expenses) of Ukraine in 2004 to that in 2008?
Provide a short and direct response. 0.99. What is the ratio of the Expenses (% of total expenses) in South Asia in 2004 to that in 2009?
Give a very brief answer. 1.22. What is the ratio of the Expenses (% of total expenses) of Belgium in 2004 to that in 2009?
Provide a short and direct response. 1.05. What is the ratio of the Expenses (% of total expenses) of Moldova in 2004 to that in 2009?
Offer a very short reply. 0.92. What is the ratio of the Expenses (% of total expenses) in Ukraine in 2004 to that in 2009?
Ensure brevity in your answer.  0.92. What is the ratio of the Expenses (% of total expenses) in South Asia in 2005 to that in 2006?
Provide a short and direct response. 1.02. What is the ratio of the Expenses (% of total expenses) in Moldova in 2005 to that in 2006?
Make the answer very short. 0.92. What is the ratio of the Expenses (% of total expenses) of Ukraine in 2005 to that in 2006?
Offer a very short reply. 1.05. What is the ratio of the Expenses (% of total expenses) in South Asia in 2005 to that in 2007?
Offer a terse response. 1.14. What is the ratio of the Expenses (% of total expenses) in Belgium in 2005 to that in 2007?
Keep it short and to the point. 0.95. What is the ratio of the Expenses (% of total expenses) in Moldova in 2005 to that in 2007?
Provide a succinct answer. 0.96. What is the ratio of the Expenses (% of total expenses) in Ukraine in 2005 to that in 2007?
Provide a succinct answer. 1.02. What is the ratio of the Expenses (% of total expenses) in South Asia in 2005 to that in 2008?
Offer a very short reply. 1.03. What is the ratio of the Expenses (% of total expenses) in Belgium in 2005 to that in 2008?
Provide a succinct answer. 0.89. What is the ratio of the Expenses (% of total expenses) of Moldova in 2005 to that in 2008?
Provide a short and direct response. 0.9. What is the ratio of the Expenses (% of total expenses) of Ukraine in 2005 to that in 2008?
Keep it short and to the point. 1.09. What is the ratio of the Expenses (% of total expenses) of South Asia in 2005 to that in 2009?
Your answer should be very brief. 1.19. What is the ratio of the Expenses (% of total expenses) in Belgium in 2005 to that in 2009?
Offer a terse response. 0.97. What is the ratio of the Expenses (% of total expenses) in Moldova in 2005 to that in 2009?
Your answer should be compact. 0.92. What is the ratio of the Expenses (% of total expenses) of Ukraine in 2005 to that in 2009?
Make the answer very short. 1.01. What is the ratio of the Expenses (% of total expenses) in South Asia in 2006 to that in 2007?
Your response must be concise. 1.12. What is the ratio of the Expenses (% of total expenses) of Belgium in 2006 to that in 2007?
Offer a terse response. 0.96. What is the ratio of the Expenses (% of total expenses) of Moldova in 2006 to that in 2007?
Offer a terse response. 1.04. What is the ratio of the Expenses (% of total expenses) of Ukraine in 2006 to that in 2007?
Your response must be concise. 0.97. What is the ratio of the Expenses (% of total expenses) of South Asia in 2006 to that in 2008?
Keep it short and to the point. 1.02. What is the ratio of the Expenses (% of total expenses) of Belgium in 2006 to that in 2008?
Your response must be concise. 0.9. What is the ratio of the Expenses (% of total expenses) in Moldova in 2006 to that in 2008?
Provide a succinct answer. 0.97. What is the ratio of the Expenses (% of total expenses) in Ukraine in 2006 to that in 2008?
Keep it short and to the point. 1.04. What is the ratio of the Expenses (% of total expenses) in South Asia in 2006 to that in 2009?
Provide a short and direct response. 1.17. What is the ratio of the Expenses (% of total expenses) of Belgium in 2006 to that in 2009?
Offer a very short reply. 0.98. What is the ratio of the Expenses (% of total expenses) in Ukraine in 2006 to that in 2009?
Give a very brief answer. 0.96. What is the ratio of the Expenses (% of total expenses) in South Asia in 2007 to that in 2008?
Offer a terse response. 0.91. What is the ratio of the Expenses (% of total expenses) of Belgium in 2007 to that in 2008?
Keep it short and to the point. 0.93. What is the ratio of the Expenses (% of total expenses) of Moldova in 2007 to that in 2008?
Your response must be concise. 0.93. What is the ratio of the Expenses (% of total expenses) of Ukraine in 2007 to that in 2008?
Provide a succinct answer. 1.07. What is the ratio of the Expenses (% of total expenses) in South Asia in 2007 to that in 2009?
Offer a terse response. 1.04. What is the ratio of the Expenses (% of total expenses) in Belgium in 2007 to that in 2009?
Provide a succinct answer. 1.01. What is the ratio of the Expenses (% of total expenses) of Moldova in 2007 to that in 2009?
Give a very brief answer. 0.95. What is the ratio of the Expenses (% of total expenses) in Ukraine in 2007 to that in 2009?
Provide a succinct answer. 0.99. What is the ratio of the Expenses (% of total expenses) of South Asia in 2008 to that in 2009?
Provide a succinct answer. 1.15. What is the ratio of the Expenses (% of total expenses) in Belgium in 2008 to that in 2009?
Give a very brief answer. 1.09. What is the ratio of the Expenses (% of total expenses) of Moldova in 2008 to that in 2009?
Provide a succinct answer. 1.02. What is the ratio of the Expenses (% of total expenses) in Ukraine in 2008 to that in 2009?
Give a very brief answer. 0.93. What is the difference between the highest and the second highest Expenses (% of total expenses) of South Asia?
Your answer should be very brief. 1.58. What is the difference between the highest and the second highest Expenses (% of total expenses) in Belgium?
Provide a succinct answer. 0.09. What is the difference between the highest and the second highest Expenses (% of total expenses) of Moldova?
Offer a terse response. 0.31. What is the difference between the highest and the second highest Expenses (% of total expenses) in Ukraine?
Provide a succinct answer. 0.65. What is the difference between the highest and the lowest Expenses (% of total expenses) of South Asia?
Your response must be concise. 4.34. What is the difference between the highest and the lowest Expenses (% of total expenses) of Belgium?
Make the answer very short. 0.3. What is the difference between the highest and the lowest Expenses (% of total expenses) of Moldova?
Your answer should be compact. 11.38. What is the difference between the highest and the lowest Expenses (% of total expenses) in Ukraine?
Make the answer very short. 3.61. 